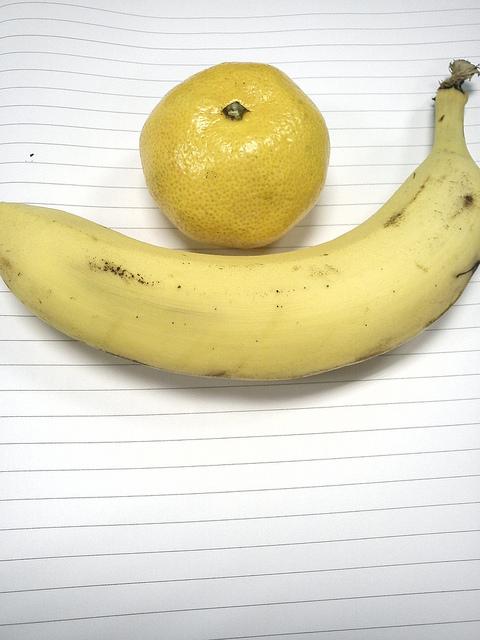Is this French?
Answer briefly. No. How many citrus fruits are there?
Give a very brief answer. 1. What color is the apple?
Short answer required. Yellow. Is there a banana next to the apple?
Answer briefly. No. What fruit is shown?
Write a very short answer. Banana and orange. How many pieces of fruit are there?
Short answer required. 2. 